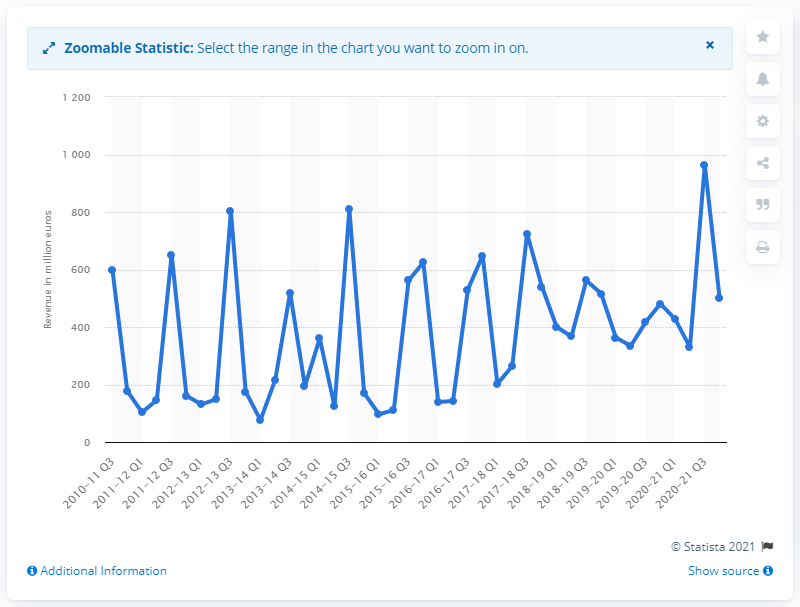Specify some key components in this picture. Ubisoft generated approximately $501.8 million in revenue during the fourth quarter of the fiscal year 2020-21. 